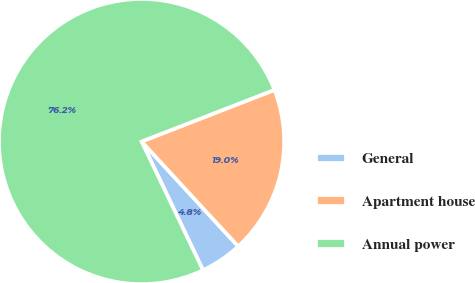Convert chart. <chart><loc_0><loc_0><loc_500><loc_500><pie_chart><fcel>General<fcel>Apartment house<fcel>Annual power<nl><fcel>4.76%<fcel>19.05%<fcel>76.19%<nl></chart> 